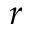Convert formula to latex. <formula><loc_0><loc_0><loc_500><loc_500>r</formula> 